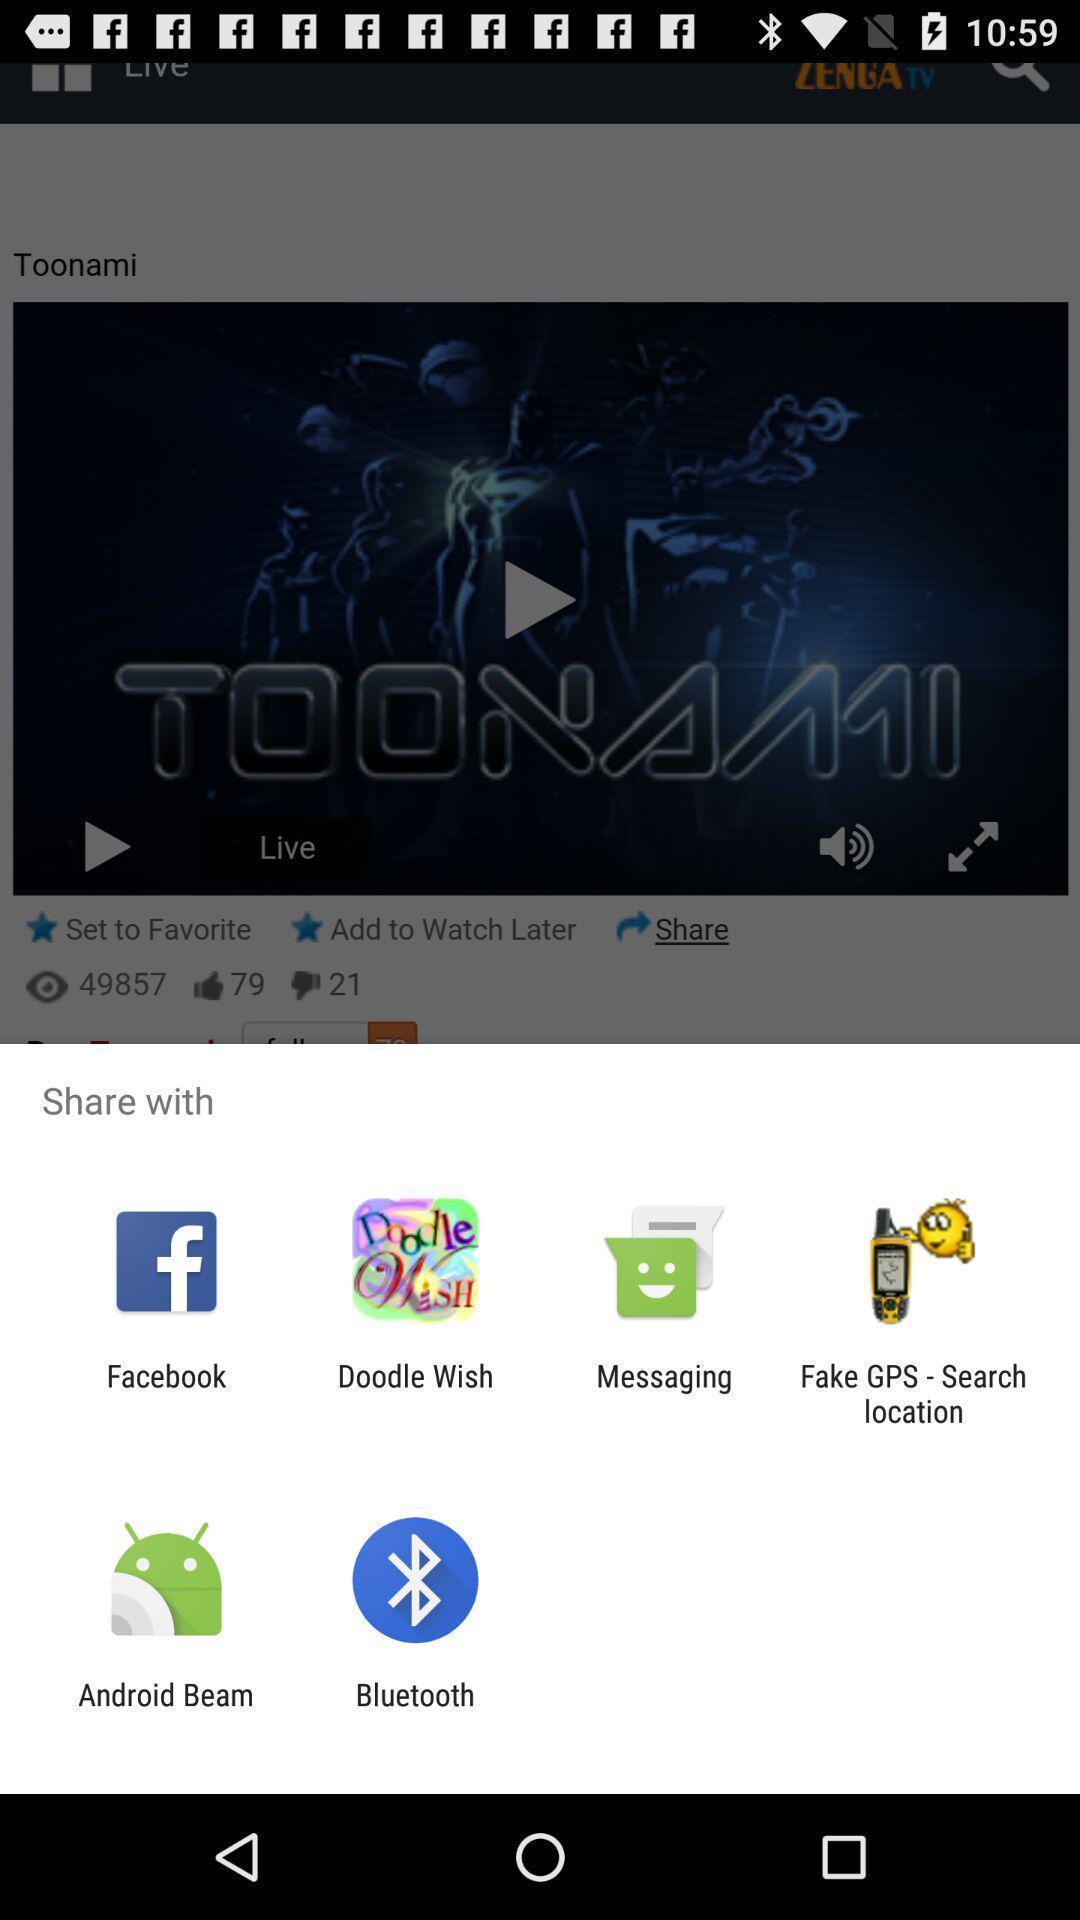Describe this image in words. Popup applications to share the information. 